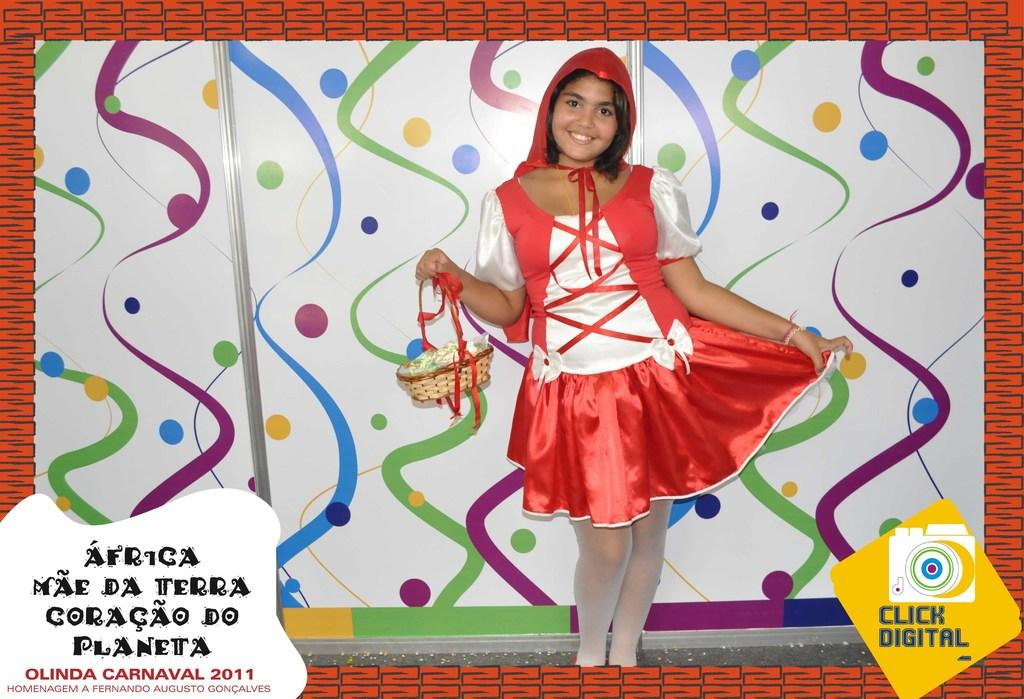What is the main subject of the image? There is a woman in the image. What is the woman doing in the image? The woman is standing on the floor and holding a basket in her hand. What can be seen in the background of the image? There is a board in the background of the image. How has the image been modified? The image has been edited with a frame. What type of voice can be heard coming from the woman in the image? There is no sound or voice present in the image, as it is a still photograph. How many sons does the woman have, and are they visible in the image? There is no information about the woman's sons in the image, and no other people are visible. 